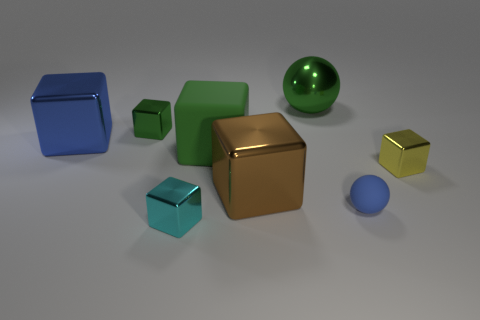There is a shiny block that is the same color as the small sphere; what size is it?
Offer a terse response. Large. How many cyan things are either large matte blocks or large metal balls?
Ensure brevity in your answer.  0. Is there a large matte cube that is behind the shiny object that is on the right side of the large thing that is behind the tiny green thing?
Make the answer very short. Yes. What shape is the large object that is the same color as the tiny sphere?
Keep it short and to the point. Cube. Is there anything else that is made of the same material as the cyan block?
Offer a very short reply. Yes. What number of tiny things are either cyan metal cubes or cubes?
Give a very brief answer. 3. There is a small metal thing behind the big matte thing; is it the same shape as the small blue rubber thing?
Provide a succinct answer. No. Are there fewer tiny red balls than small green cubes?
Offer a very short reply. Yes. Is there any other thing of the same color as the tiny rubber thing?
Keep it short and to the point. Yes. What is the shape of the blue object that is to the right of the large green metallic ball?
Keep it short and to the point. Sphere. 